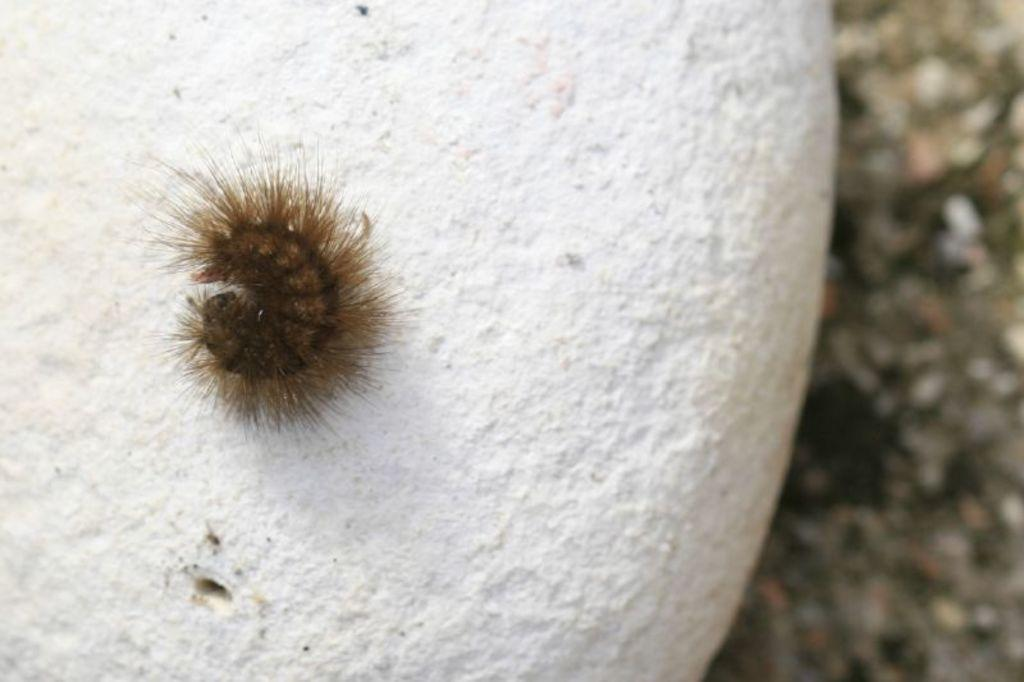What type of insect is in the image? There is a black color caterpillar in the image. What is the caterpillar placed on? The caterpillar is placed on a white color stone. What can be seen on the right side of the image? The ground is visible on the right side of the image. What is the profit made by the caterpillar in the image? There is no mention of profit in the image, as it features a caterpillar on a stone. Can you see the arm of the caterpillar in the image? Caterpillars do not have arms; they have legs and other body parts, but no arms are visible in the image. 